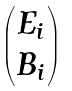<formula> <loc_0><loc_0><loc_500><loc_500>\begin{pmatrix} E _ { i } \\ B _ { i } \\ \end{pmatrix}</formula> 